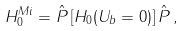Convert formula to latex. <formula><loc_0><loc_0><loc_500><loc_500>H _ { 0 } ^ { M i } = \hat { P } \left [ H _ { 0 } ( U _ { b } = 0 ) \right ] \hat { P } \, ,</formula> 